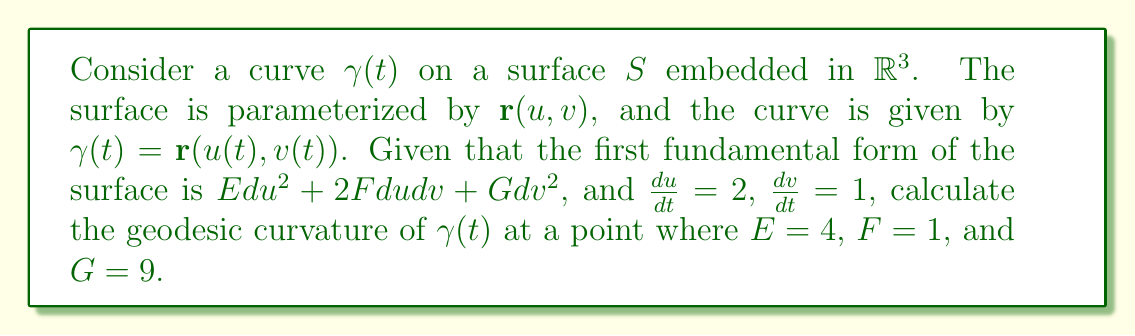Provide a solution to this math problem. To calculate the geodesic curvature of the curve $\gamma(t)$ on the surface $S$, we'll follow these steps:

1) The geodesic curvature $\kappa_g$ is given by the formula:

   $$\kappa_g = \frac{1}{\sqrt{EG-F^2}}\left|\begin{array}{ccc}
   E & F & \frac{1}{2}E_u\dot{u} + E_v\dot{v} \\
   F & G & \frac{1}{2}G_u\dot{u} + G_v\dot{v} \\
   \dot{u} & \dot{v} & \ddot{u}\dot{v} - \dot{u}\ddot{v}
   \end{array}\right|$$

   where $\dot{u} = \frac{du}{dt}$, $\dot{v} = \frac{dv}{dt}$, and $E_u, E_v, G_u, G_v$ are partial derivatives of $E$ and $G$ with respect to $u$ and $v$.

2) We're given that $E = 4$, $F = 1$, $G = 9$, $\dot{u} = 2$, and $\dot{v} = 1$.

3) Calculate $\sqrt{EG-F^2}$:
   
   $$\sqrt{EG-F^2} = \sqrt{4 \cdot 9 - 1^2} = \sqrt{35}$$

4) We don't have information about $E_u, E_v, G_u, G_v$, or $\ddot{u}$ and $\ddot{v}$. However, we can express the geodesic curvature in terms of these unknowns:

   $$\kappa_g = \frac{1}{\sqrt{35}}\left|\begin{array}{ccc}
   4 & 1 & 2E_u + E_v \\
   1 & 9 & G_u + 9G_v \\
   2 & 1 & 2\ddot{v} - \ddot{u}
   \end{array}\right|$$

5) Expanding the determinant:

   $$\kappa_g = \frac{1}{\sqrt{35}}[4(9(2\ddot{v} - \ddot{u}) - (G_u + 9G_v)) - 1(1(2\ddot{v} - \ddot{u}) - 2(G_u + 9G_v)) + (2E_u + E_v)(9 - 2)]$$

6) Simplifying:

   $$\kappa_g = \frac{1}{\sqrt{35}}[36\ddot{v} - 18\ddot{u} - 4G_u - 36G_v - 2\ddot{v} + \ddot{u} + 2G_u + 18G_v + 14E_u + 7E_v]$$
   
   $$\kappa_g = \frac{1}{\sqrt{35}}[34\ddot{v} - 17\ddot{u} - 2G_u - 18G_v + 14E_u + 7E_v]$$

This is the most simplified form we can achieve without additional information about the partial derivatives and second derivatives.
Answer: $\kappa_g = \frac{34\ddot{v} - 17\ddot{u} - 2G_u - 18G_v + 14E_u + 7E_v}{\sqrt{35}}$ 